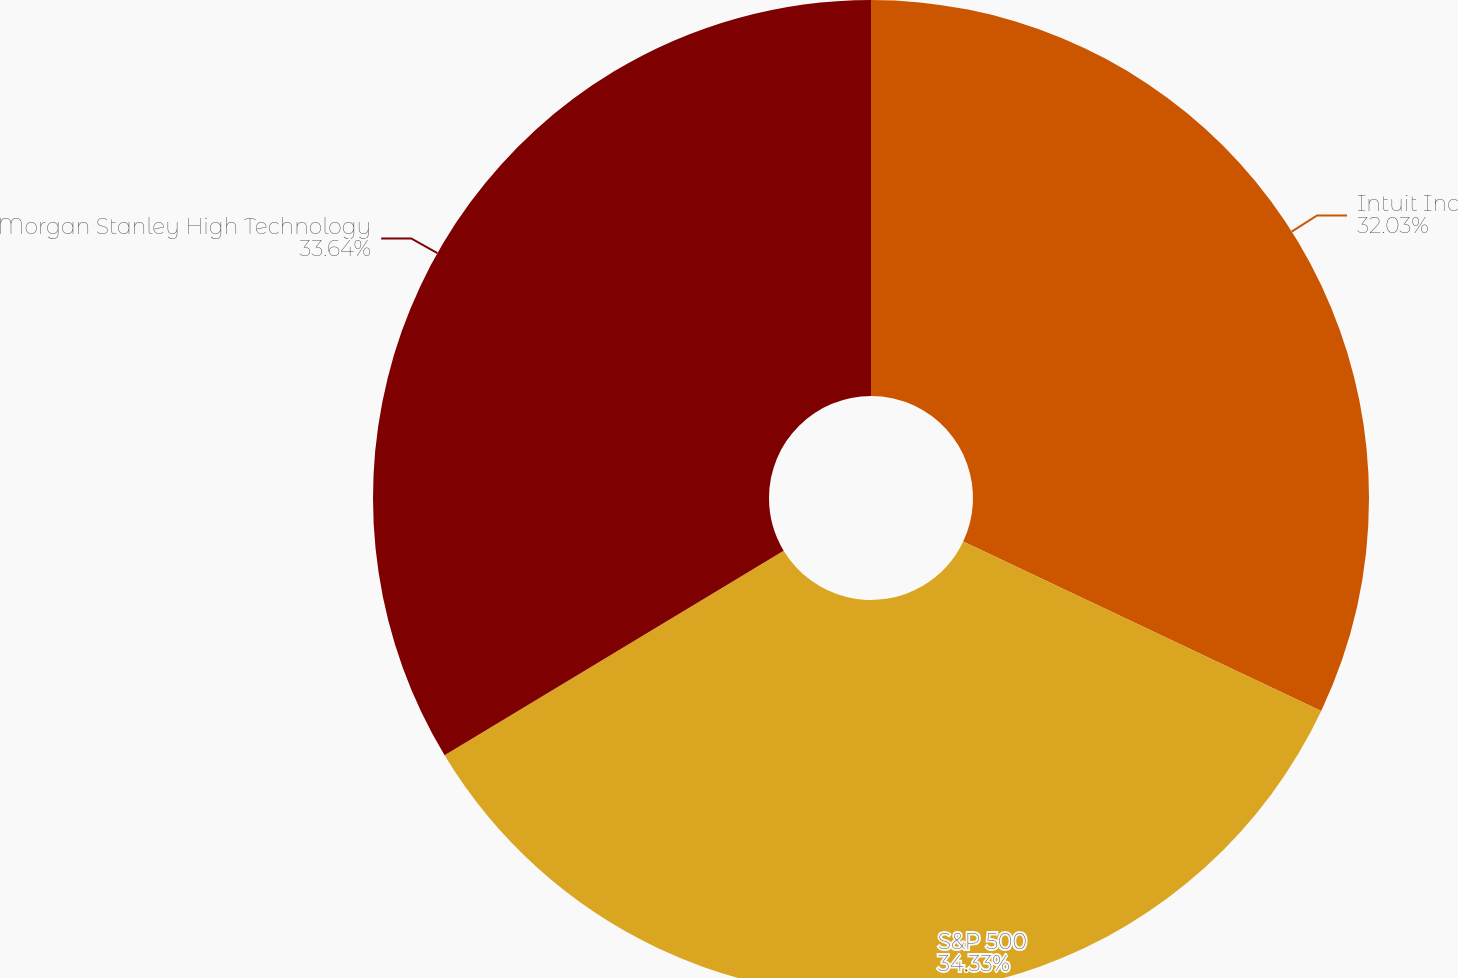Convert chart to OTSL. <chart><loc_0><loc_0><loc_500><loc_500><pie_chart><fcel>Intuit Inc<fcel>S&P 500<fcel>Morgan Stanley High Technology<nl><fcel>32.03%<fcel>34.33%<fcel>33.64%<nl></chart> 